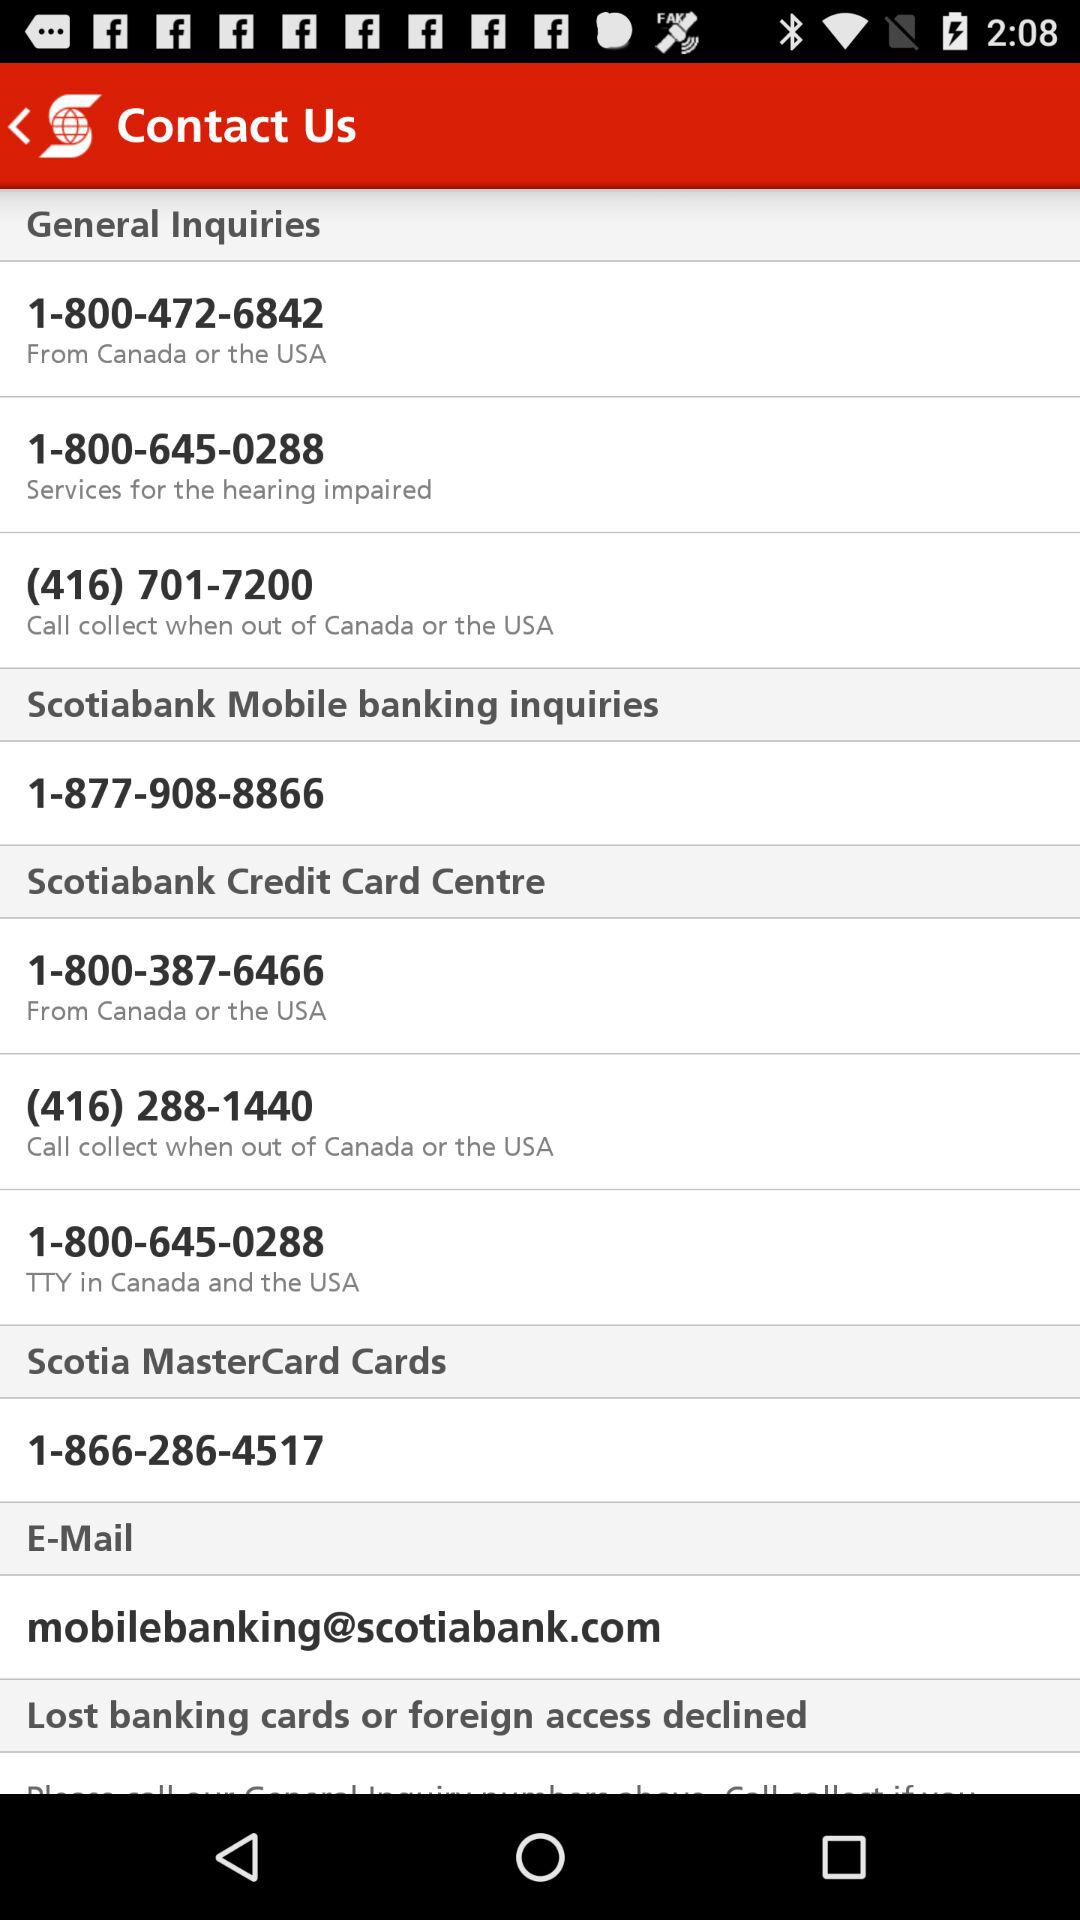What's the email address? The email address is mobilebanking@scotiabank.com. 